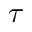<formula> <loc_0><loc_0><loc_500><loc_500>\tau</formula> 